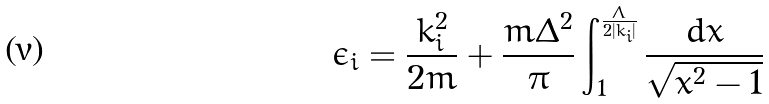<formula> <loc_0><loc_0><loc_500><loc_500>\epsilon _ { i } = \frac { k ^ { 2 } _ { i } } { 2 m } + \frac { m \Delta ^ { 2 } } { \pi } \int ^ { \frac { \Lambda } { 2 | k _ { i } | } } _ { 1 } \frac { d x } { \sqrt { x ^ { 2 } - 1 } }</formula> 